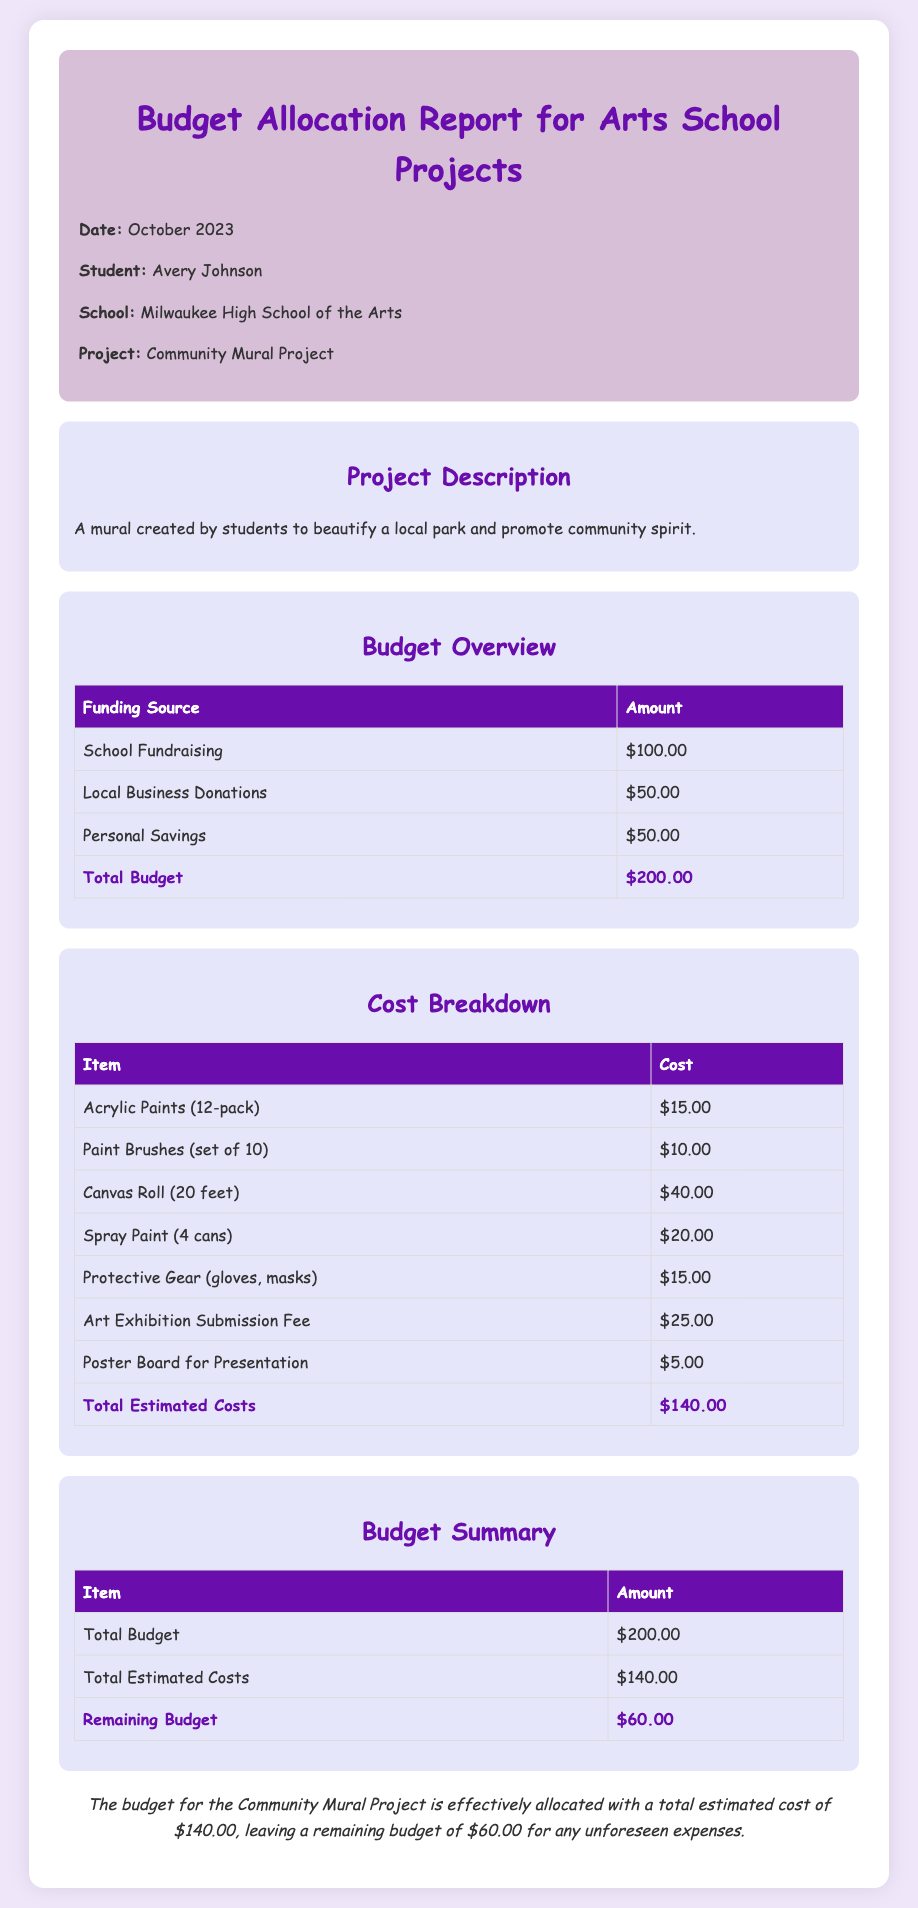What is the total budget? The total budget is found in the Budget Overview section of the document, which lists the total amount allocated for the project.
Answer: $200.00 What is the cost of the canvas roll? The cost for the canvas roll can be found in the Cost Breakdown section, detailing the individual item costs.
Answer: $40.00 When was the report created? The date of the report is provided in the header, indicating when the budget allocation report was compiled.
Answer: October 2023 How much funding comes from local business donations? The amount from local business donations is specified under the Budget Overview section of the report.
Answer: $50.00 What is the remaining budget after estimated costs? The remaining budget is calculated as Total Budget minus Total Estimated Costs, provided in the Budget Summary section.
Answer: $60.00 How much does the art exhibition submission fee cost? The cost of the art exhibition submission fee is listed in the breakdown of costs for the project.
Answer: $25.00 What is the purpose of the Community Mural Project? The purpose of the project is described in the Project Description section of the document, outlining the goals of the project.
Answer: Beautify a local park What is the total estimated cost of materials? The total estimated cost is provided in the Cost Breakdown section, summarizing the overall costs associated with the project.
Answer: $140.00 